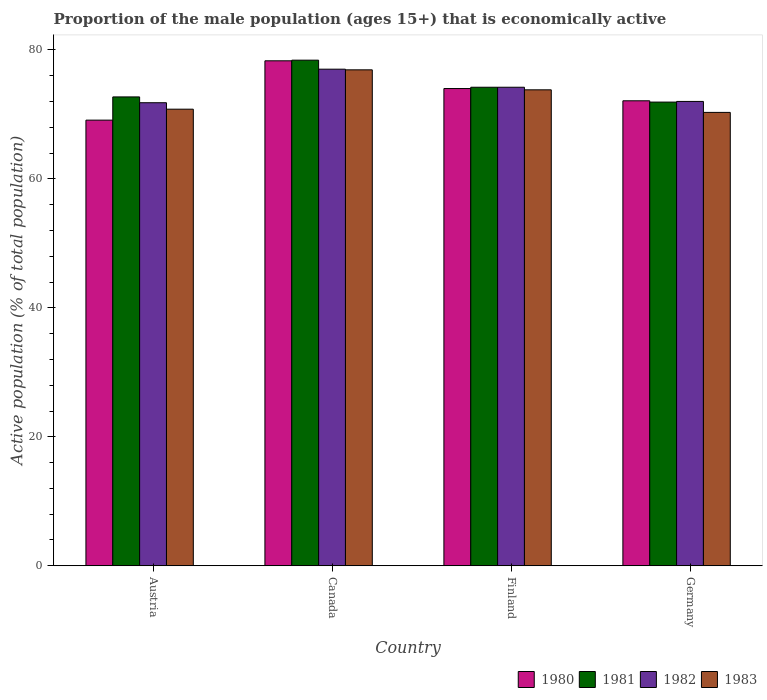How many different coloured bars are there?
Your answer should be compact. 4. Are the number of bars per tick equal to the number of legend labels?
Your answer should be compact. Yes. Are the number of bars on each tick of the X-axis equal?
Your answer should be very brief. Yes. How many bars are there on the 4th tick from the left?
Your response must be concise. 4. How many bars are there on the 2nd tick from the right?
Make the answer very short. 4. What is the proportion of the male population that is economically active in 1981 in Germany?
Provide a succinct answer. 71.9. Across all countries, what is the maximum proportion of the male population that is economically active in 1981?
Ensure brevity in your answer.  78.4. Across all countries, what is the minimum proportion of the male population that is economically active in 1983?
Make the answer very short. 70.3. In which country was the proportion of the male population that is economically active in 1981 maximum?
Make the answer very short. Canada. What is the total proportion of the male population that is economically active in 1980 in the graph?
Provide a succinct answer. 293.5. What is the difference between the proportion of the male population that is economically active in 1983 in Austria and that in Canada?
Provide a succinct answer. -6.1. What is the difference between the proportion of the male population that is economically active in 1983 in Finland and the proportion of the male population that is economically active in 1981 in Germany?
Your answer should be compact. 1.9. What is the average proportion of the male population that is economically active in 1981 per country?
Keep it short and to the point. 74.3. What is the difference between the proportion of the male population that is economically active of/in 1983 and proportion of the male population that is economically active of/in 1982 in Germany?
Your answer should be very brief. -1.7. What is the ratio of the proportion of the male population that is economically active in 1981 in Canada to that in Finland?
Keep it short and to the point. 1.06. Is the proportion of the male population that is economically active in 1981 in Canada less than that in Finland?
Make the answer very short. No. Is the difference between the proportion of the male population that is economically active in 1983 in Canada and Finland greater than the difference between the proportion of the male population that is economically active in 1982 in Canada and Finland?
Offer a very short reply. Yes. What is the difference between the highest and the second highest proportion of the male population that is economically active in 1982?
Your answer should be very brief. -2.2. What is the difference between the highest and the lowest proportion of the male population that is economically active in 1983?
Your answer should be compact. 6.6. In how many countries, is the proportion of the male population that is economically active in 1983 greater than the average proportion of the male population that is economically active in 1983 taken over all countries?
Provide a succinct answer. 2. Is the sum of the proportion of the male population that is economically active in 1983 in Austria and Canada greater than the maximum proportion of the male population that is economically active in 1982 across all countries?
Give a very brief answer. Yes. Is it the case that in every country, the sum of the proportion of the male population that is economically active in 1980 and proportion of the male population that is economically active in 1981 is greater than the sum of proportion of the male population that is economically active in 1982 and proportion of the male population that is economically active in 1983?
Your answer should be compact. No. What does the 3rd bar from the right in Germany represents?
Offer a terse response. 1981. How many bars are there?
Give a very brief answer. 16. How many countries are there in the graph?
Make the answer very short. 4. Does the graph contain grids?
Your response must be concise. No. Where does the legend appear in the graph?
Offer a very short reply. Bottom right. How many legend labels are there?
Make the answer very short. 4. What is the title of the graph?
Keep it short and to the point. Proportion of the male population (ages 15+) that is economically active. What is the label or title of the Y-axis?
Your response must be concise. Active population (% of total population). What is the Active population (% of total population) of 1980 in Austria?
Your answer should be very brief. 69.1. What is the Active population (% of total population) of 1981 in Austria?
Make the answer very short. 72.7. What is the Active population (% of total population) of 1982 in Austria?
Give a very brief answer. 71.8. What is the Active population (% of total population) in 1983 in Austria?
Keep it short and to the point. 70.8. What is the Active population (% of total population) of 1980 in Canada?
Make the answer very short. 78.3. What is the Active population (% of total population) of 1981 in Canada?
Make the answer very short. 78.4. What is the Active population (% of total population) of 1982 in Canada?
Your answer should be compact. 77. What is the Active population (% of total population) of 1983 in Canada?
Your answer should be very brief. 76.9. What is the Active population (% of total population) in 1981 in Finland?
Offer a terse response. 74.2. What is the Active population (% of total population) of 1982 in Finland?
Offer a very short reply. 74.2. What is the Active population (% of total population) of 1983 in Finland?
Your answer should be compact. 73.8. What is the Active population (% of total population) in 1980 in Germany?
Ensure brevity in your answer.  72.1. What is the Active population (% of total population) of 1981 in Germany?
Offer a terse response. 71.9. What is the Active population (% of total population) of 1982 in Germany?
Provide a short and direct response. 72. What is the Active population (% of total population) of 1983 in Germany?
Keep it short and to the point. 70.3. Across all countries, what is the maximum Active population (% of total population) of 1980?
Make the answer very short. 78.3. Across all countries, what is the maximum Active population (% of total population) in 1981?
Offer a very short reply. 78.4. Across all countries, what is the maximum Active population (% of total population) of 1982?
Provide a short and direct response. 77. Across all countries, what is the maximum Active population (% of total population) in 1983?
Ensure brevity in your answer.  76.9. Across all countries, what is the minimum Active population (% of total population) of 1980?
Keep it short and to the point. 69.1. Across all countries, what is the minimum Active population (% of total population) of 1981?
Your answer should be compact. 71.9. Across all countries, what is the minimum Active population (% of total population) of 1982?
Your answer should be very brief. 71.8. Across all countries, what is the minimum Active population (% of total population) in 1983?
Provide a short and direct response. 70.3. What is the total Active population (% of total population) in 1980 in the graph?
Make the answer very short. 293.5. What is the total Active population (% of total population) of 1981 in the graph?
Your answer should be compact. 297.2. What is the total Active population (% of total population) in 1982 in the graph?
Offer a terse response. 295. What is the total Active population (% of total population) of 1983 in the graph?
Offer a terse response. 291.8. What is the difference between the Active population (% of total population) in 1981 in Austria and that in Canada?
Your response must be concise. -5.7. What is the difference between the Active population (% of total population) of 1980 in Austria and that in Finland?
Make the answer very short. -4.9. What is the difference between the Active population (% of total population) of 1983 in Austria and that in Finland?
Provide a short and direct response. -3. What is the difference between the Active population (% of total population) in 1980 in Austria and that in Germany?
Ensure brevity in your answer.  -3. What is the difference between the Active population (% of total population) of 1983 in Austria and that in Germany?
Make the answer very short. 0.5. What is the difference between the Active population (% of total population) in 1981 in Canada and that in Finland?
Your response must be concise. 4.2. What is the difference between the Active population (% of total population) in 1980 in Canada and that in Germany?
Your answer should be very brief. 6.2. What is the difference between the Active population (% of total population) of 1981 in Canada and that in Germany?
Provide a short and direct response. 6.5. What is the difference between the Active population (% of total population) in 1982 in Canada and that in Germany?
Your answer should be compact. 5. What is the difference between the Active population (% of total population) in 1983 in Canada and that in Germany?
Your answer should be compact. 6.6. What is the difference between the Active population (% of total population) in 1982 in Finland and that in Germany?
Provide a succinct answer. 2.2. What is the difference between the Active population (% of total population) of 1983 in Finland and that in Germany?
Keep it short and to the point. 3.5. What is the difference between the Active population (% of total population) of 1980 in Austria and the Active population (% of total population) of 1982 in Canada?
Your response must be concise. -7.9. What is the difference between the Active population (% of total population) of 1980 in Austria and the Active population (% of total population) of 1983 in Canada?
Your answer should be very brief. -7.8. What is the difference between the Active population (% of total population) in 1982 in Austria and the Active population (% of total population) in 1983 in Canada?
Offer a terse response. -5.1. What is the difference between the Active population (% of total population) in 1980 in Austria and the Active population (% of total population) in 1981 in Finland?
Keep it short and to the point. -5.1. What is the difference between the Active population (% of total population) of 1980 in Austria and the Active population (% of total population) of 1983 in Finland?
Give a very brief answer. -4.7. What is the difference between the Active population (% of total population) in 1981 in Austria and the Active population (% of total population) in 1982 in Finland?
Provide a short and direct response. -1.5. What is the difference between the Active population (% of total population) of 1980 in Austria and the Active population (% of total population) of 1981 in Germany?
Your answer should be compact. -2.8. What is the difference between the Active population (% of total population) of 1980 in Austria and the Active population (% of total population) of 1983 in Germany?
Offer a very short reply. -1.2. What is the difference between the Active population (% of total population) in 1982 in Austria and the Active population (% of total population) in 1983 in Germany?
Provide a short and direct response. 1.5. What is the difference between the Active population (% of total population) of 1980 in Canada and the Active population (% of total population) of 1981 in Finland?
Your response must be concise. 4.1. What is the difference between the Active population (% of total population) in 1980 in Finland and the Active population (% of total population) in 1981 in Germany?
Provide a succinct answer. 2.1. What is the difference between the Active population (% of total population) in 1980 in Finland and the Active population (% of total population) in 1982 in Germany?
Make the answer very short. 2. What is the difference between the Active population (% of total population) of 1980 in Finland and the Active population (% of total population) of 1983 in Germany?
Keep it short and to the point. 3.7. What is the difference between the Active population (% of total population) of 1981 in Finland and the Active population (% of total population) of 1982 in Germany?
Ensure brevity in your answer.  2.2. What is the difference between the Active population (% of total population) of 1982 in Finland and the Active population (% of total population) of 1983 in Germany?
Provide a succinct answer. 3.9. What is the average Active population (% of total population) of 1980 per country?
Provide a succinct answer. 73.38. What is the average Active population (% of total population) in 1981 per country?
Make the answer very short. 74.3. What is the average Active population (% of total population) in 1982 per country?
Make the answer very short. 73.75. What is the average Active population (% of total population) in 1983 per country?
Ensure brevity in your answer.  72.95. What is the difference between the Active population (% of total population) of 1980 and Active population (% of total population) of 1982 in Austria?
Offer a terse response. -2.7. What is the difference between the Active population (% of total population) in 1980 and Active population (% of total population) in 1983 in Austria?
Your response must be concise. -1.7. What is the difference between the Active population (% of total population) in 1981 and Active population (% of total population) in 1982 in Austria?
Keep it short and to the point. 0.9. What is the difference between the Active population (% of total population) of 1982 and Active population (% of total population) of 1983 in Austria?
Provide a succinct answer. 1. What is the difference between the Active population (% of total population) of 1980 and Active population (% of total population) of 1982 in Canada?
Give a very brief answer. 1.3. What is the difference between the Active population (% of total population) of 1980 and Active population (% of total population) of 1983 in Canada?
Keep it short and to the point. 1.4. What is the difference between the Active population (% of total population) in 1981 and Active population (% of total population) in 1983 in Canada?
Ensure brevity in your answer.  1.5. What is the difference between the Active population (% of total population) in 1982 and Active population (% of total population) in 1983 in Canada?
Provide a short and direct response. 0.1. What is the difference between the Active population (% of total population) in 1980 and Active population (% of total population) in 1981 in Finland?
Your answer should be compact. -0.2. What is the difference between the Active population (% of total population) in 1981 and Active population (% of total population) in 1982 in Finland?
Give a very brief answer. 0. What is the difference between the Active population (% of total population) in 1981 and Active population (% of total population) in 1983 in Finland?
Provide a short and direct response. 0.4. What is the difference between the Active population (% of total population) of 1981 and Active population (% of total population) of 1982 in Germany?
Your response must be concise. -0.1. What is the difference between the Active population (% of total population) of 1981 and Active population (% of total population) of 1983 in Germany?
Your answer should be very brief. 1.6. What is the ratio of the Active population (% of total population) in 1980 in Austria to that in Canada?
Offer a terse response. 0.88. What is the ratio of the Active population (% of total population) of 1981 in Austria to that in Canada?
Your answer should be very brief. 0.93. What is the ratio of the Active population (% of total population) of 1982 in Austria to that in Canada?
Offer a terse response. 0.93. What is the ratio of the Active population (% of total population) in 1983 in Austria to that in Canada?
Offer a very short reply. 0.92. What is the ratio of the Active population (% of total population) of 1980 in Austria to that in Finland?
Offer a terse response. 0.93. What is the ratio of the Active population (% of total population) of 1981 in Austria to that in Finland?
Your answer should be compact. 0.98. What is the ratio of the Active population (% of total population) in 1983 in Austria to that in Finland?
Ensure brevity in your answer.  0.96. What is the ratio of the Active population (% of total population) of 1980 in Austria to that in Germany?
Your response must be concise. 0.96. What is the ratio of the Active population (% of total population) of 1981 in Austria to that in Germany?
Provide a short and direct response. 1.01. What is the ratio of the Active population (% of total population) of 1983 in Austria to that in Germany?
Provide a short and direct response. 1.01. What is the ratio of the Active population (% of total population) of 1980 in Canada to that in Finland?
Keep it short and to the point. 1.06. What is the ratio of the Active population (% of total population) of 1981 in Canada to that in Finland?
Ensure brevity in your answer.  1.06. What is the ratio of the Active population (% of total population) in 1982 in Canada to that in Finland?
Keep it short and to the point. 1.04. What is the ratio of the Active population (% of total population) of 1983 in Canada to that in Finland?
Keep it short and to the point. 1.04. What is the ratio of the Active population (% of total population) of 1980 in Canada to that in Germany?
Your answer should be compact. 1.09. What is the ratio of the Active population (% of total population) in 1981 in Canada to that in Germany?
Offer a terse response. 1.09. What is the ratio of the Active population (% of total population) in 1982 in Canada to that in Germany?
Your answer should be compact. 1.07. What is the ratio of the Active population (% of total population) in 1983 in Canada to that in Germany?
Your response must be concise. 1.09. What is the ratio of the Active population (% of total population) in 1980 in Finland to that in Germany?
Offer a terse response. 1.03. What is the ratio of the Active population (% of total population) in 1981 in Finland to that in Germany?
Give a very brief answer. 1.03. What is the ratio of the Active population (% of total population) of 1982 in Finland to that in Germany?
Make the answer very short. 1.03. What is the ratio of the Active population (% of total population) of 1983 in Finland to that in Germany?
Your answer should be very brief. 1.05. What is the difference between the highest and the second highest Active population (% of total population) of 1980?
Your answer should be very brief. 4.3. What is the difference between the highest and the second highest Active population (% of total population) in 1981?
Offer a terse response. 4.2. What is the difference between the highest and the lowest Active population (% of total population) of 1980?
Your answer should be very brief. 9.2. What is the difference between the highest and the lowest Active population (% of total population) of 1981?
Give a very brief answer. 6.5. What is the difference between the highest and the lowest Active population (% of total population) in 1983?
Give a very brief answer. 6.6. 